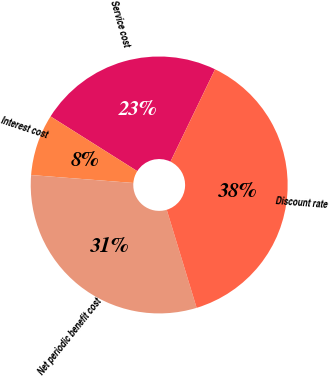<chart> <loc_0><loc_0><loc_500><loc_500><pie_chart><fcel>Service cost<fcel>Interest cost<fcel>Net periodic benefit cost<fcel>Discount rate<nl><fcel>23.2%<fcel>7.73%<fcel>30.94%<fcel>38.13%<nl></chart> 